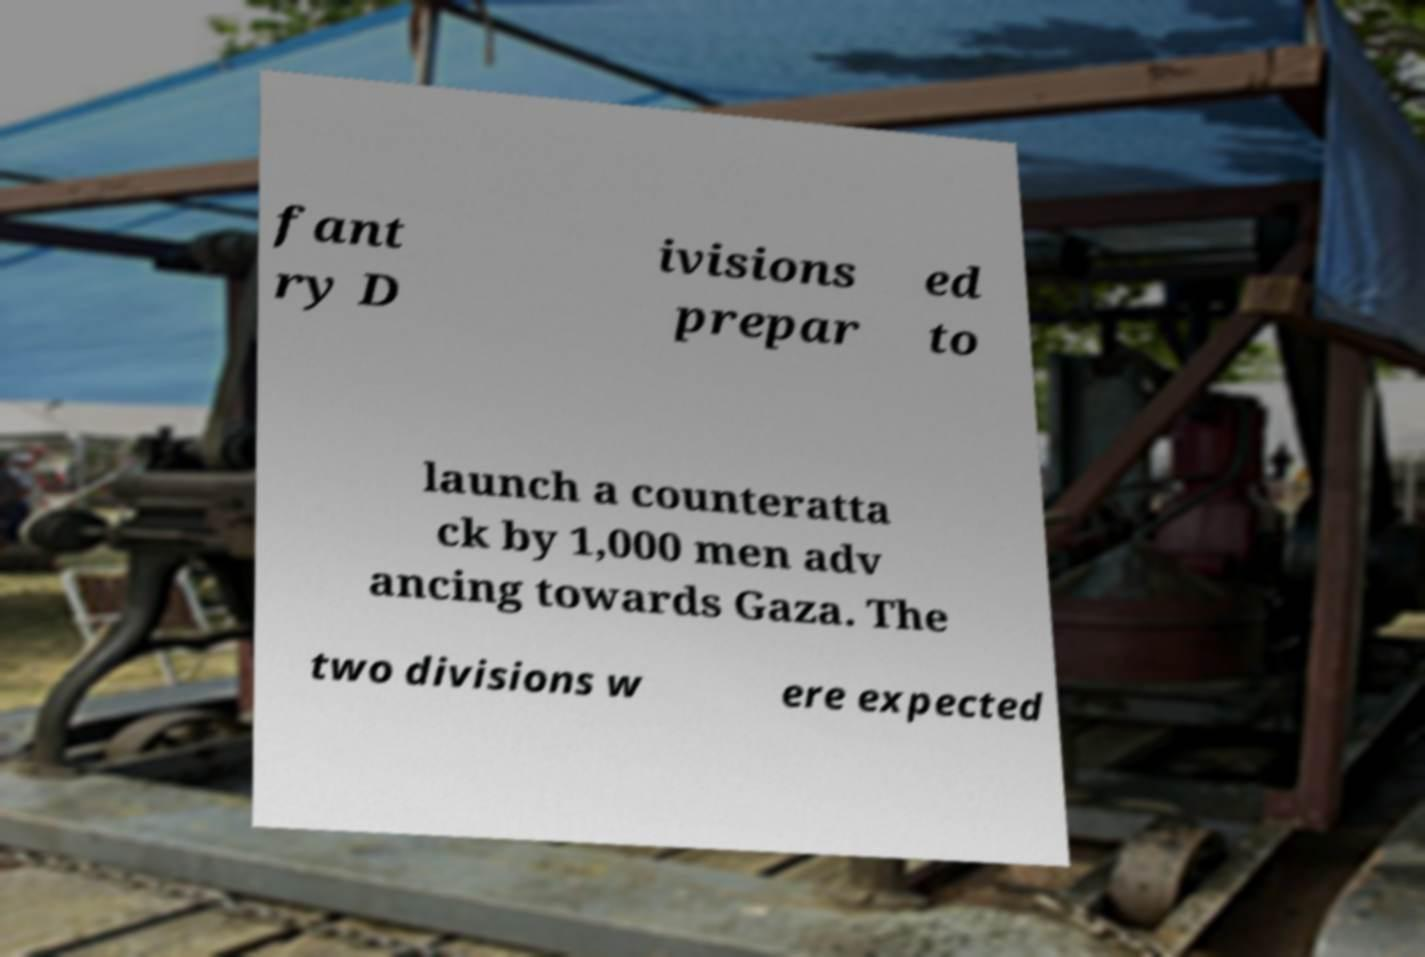What messages or text are displayed in this image? I need them in a readable, typed format. fant ry D ivisions prepar ed to launch a counteratta ck by 1,000 men adv ancing towards Gaza. The two divisions w ere expected 